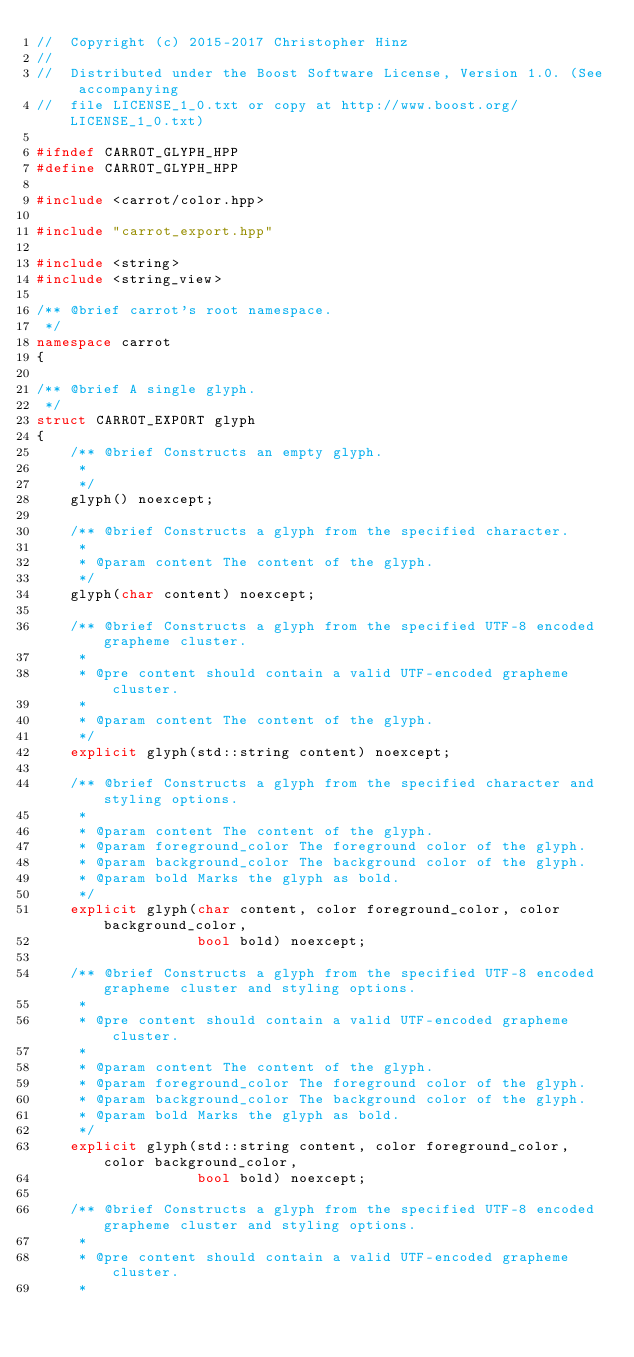<code> <loc_0><loc_0><loc_500><loc_500><_C++_>//  Copyright (c) 2015-2017 Christopher Hinz
//
//  Distributed under the Boost Software License, Version 1.0. (See accompanying
//  file LICENSE_1_0.txt or copy at http://www.boost.org/LICENSE_1_0.txt)

#ifndef CARROT_GLYPH_HPP
#define CARROT_GLYPH_HPP

#include <carrot/color.hpp>

#include "carrot_export.hpp"

#include <string>
#include <string_view>

/** @brief carrot's root namespace.
 */
namespace carrot
{

/** @brief A single glyph.
 */
struct CARROT_EXPORT glyph
{
    /** @brief Constructs an empty glyph.
     *
     */
    glyph() noexcept;

    /** @brief Constructs a glyph from the specified character.
     *
     * @param content The content of the glyph.
     */
    glyph(char content) noexcept;

    /** @brief Constructs a glyph from the specified UTF-8 encoded grapheme cluster.
     *
     * @pre content should contain a valid UTF-encoded grapheme cluster.
     *
     * @param content The content of the glyph.
     */
    explicit glyph(std::string content) noexcept;

    /** @brief Constructs a glyph from the specified character and styling options.
     *
     * @param content The content of the glyph.
     * @param foreground_color The foreground color of the glyph.
     * @param background_color The background color of the glyph.
     * @param bold Marks the glyph as bold.
     */
    explicit glyph(char content, color foreground_color, color background_color,
                   bool bold) noexcept;

    /** @brief Constructs a glyph from the specified UTF-8 encoded grapheme cluster and styling options.
     *
     * @pre content should contain a valid UTF-encoded grapheme cluster.
     *
     * @param content The content of the glyph.
     * @param foreground_color The foreground color of the glyph.
     * @param background_color The background color of the glyph.
     * @param bold Marks the glyph as bold.
     */
    explicit glyph(std::string content, color foreground_color, color background_color,
                   bool bold) noexcept;

    /** @brief Constructs a glyph from the specified UTF-8 encoded grapheme cluster and styling options.
     *
     * @pre content should contain a valid UTF-encoded grapheme cluster.
     *</code> 